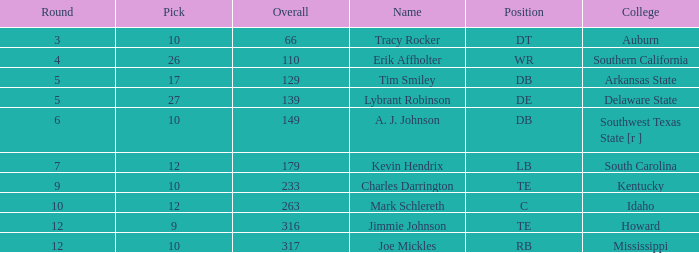What is the sum of Overall, when College is "Arkansas State", and when Pick is less than 17? None. 